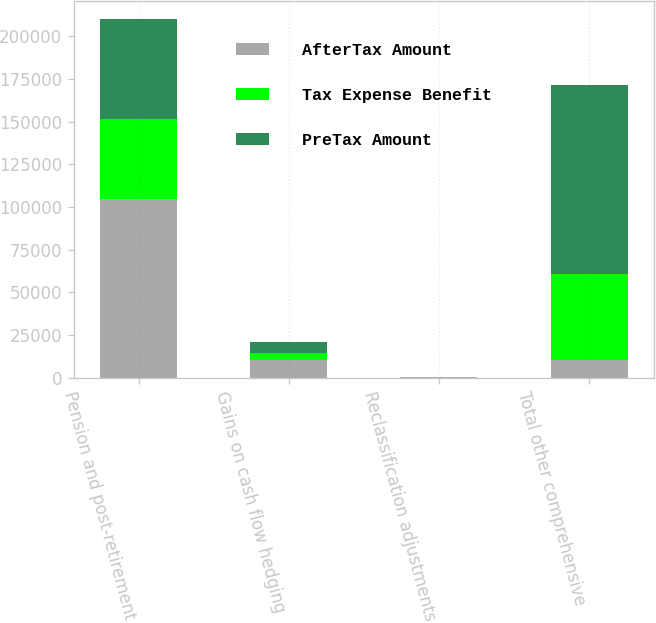Convert chart. <chart><loc_0><loc_0><loc_500><loc_500><stacked_bar_chart><ecel><fcel>Pension and post-retirement<fcel>Gains on cash flow hedging<fcel>Reclassification adjustments<fcel>Total other comprehensive<nl><fcel>AfterTax Amount<fcel>104942<fcel>10623<fcel>252<fcel>10623<nl><fcel>Tax Expense Benefit<fcel>46535<fcel>3838<fcel>79<fcel>50452<nl><fcel>PreTax Amount<fcel>58407<fcel>6785<fcel>173<fcel>110210<nl></chart> 